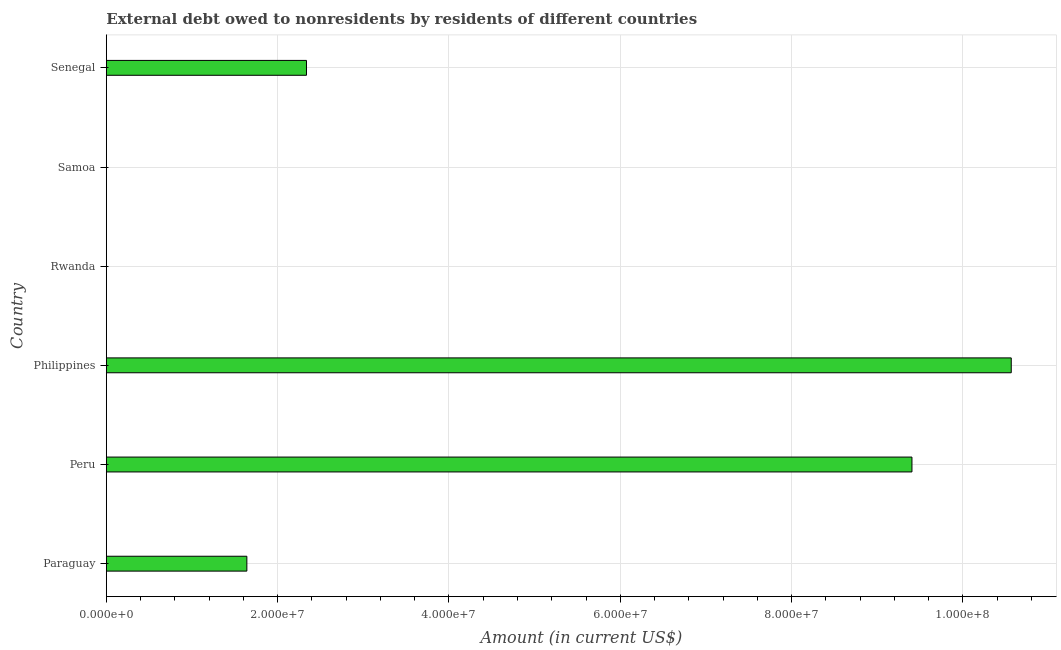Does the graph contain any zero values?
Provide a short and direct response. Yes. Does the graph contain grids?
Your answer should be very brief. Yes. What is the title of the graph?
Keep it short and to the point. External debt owed to nonresidents by residents of different countries. What is the debt in Peru?
Make the answer very short. 9.41e+07. Across all countries, what is the maximum debt?
Give a very brief answer. 1.06e+08. Across all countries, what is the minimum debt?
Your response must be concise. 0. In which country was the debt maximum?
Make the answer very short. Philippines. What is the sum of the debt?
Provide a succinct answer. 2.39e+08. What is the difference between the debt in Peru and Senegal?
Your answer should be compact. 7.07e+07. What is the average debt per country?
Keep it short and to the point. 3.99e+07. What is the median debt?
Your response must be concise. 1.99e+07. What is the ratio of the debt in Paraguay to that in Philippines?
Keep it short and to the point. 0.15. What is the difference between the highest and the second highest debt?
Provide a short and direct response. 1.16e+07. What is the difference between the highest and the lowest debt?
Provide a short and direct response. 1.06e+08. How many countries are there in the graph?
Provide a succinct answer. 6. Are the values on the major ticks of X-axis written in scientific E-notation?
Provide a short and direct response. Yes. What is the Amount (in current US$) of Paraguay?
Your response must be concise. 1.64e+07. What is the Amount (in current US$) of Peru?
Offer a very short reply. 9.41e+07. What is the Amount (in current US$) in Philippines?
Make the answer very short. 1.06e+08. What is the Amount (in current US$) in Senegal?
Make the answer very short. 2.34e+07. What is the difference between the Amount (in current US$) in Paraguay and Peru?
Offer a very short reply. -7.76e+07. What is the difference between the Amount (in current US$) in Paraguay and Philippines?
Provide a short and direct response. -8.92e+07. What is the difference between the Amount (in current US$) in Paraguay and Senegal?
Offer a terse response. -6.96e+06. What is the difference between the Amount (in current US$) in Peru and Philippines?
Make the answer very short. -1.16e+07. What is the difference between the Amount (in current US$) in Peru and Senegal?
Ensure brevity in your answer.  7.07e+07. What is the difference between the Amount (in current US$) in Philippines and Senegal?
Offer a terse response. 8.23e+07. What is the ratio of the Amount (in current US$) in Paraguay to that in Peru?
Provide a succinct answer. 0.17. What is the ratio of the Amount (in current US$) in Paraguay to that in Philippines?
Keep it short and to the point. 0.15. What is the ratio of the Amount (in current US$) in Paraguay to that in Senegal?
Offer a terse response. 0.7. What is the ratio of the Amount (in current US$) in Peru to that in Philippines?
Offer a terse response. 0.89. What is the ratio of the Amount (in current US$) in Peru to that in Senegal?
Your answer should be compact. 4.03. What is the ratio of the Amount (in current US$) in Philippines to that in Senegal?
Provide a succinct answer. 4.52. 